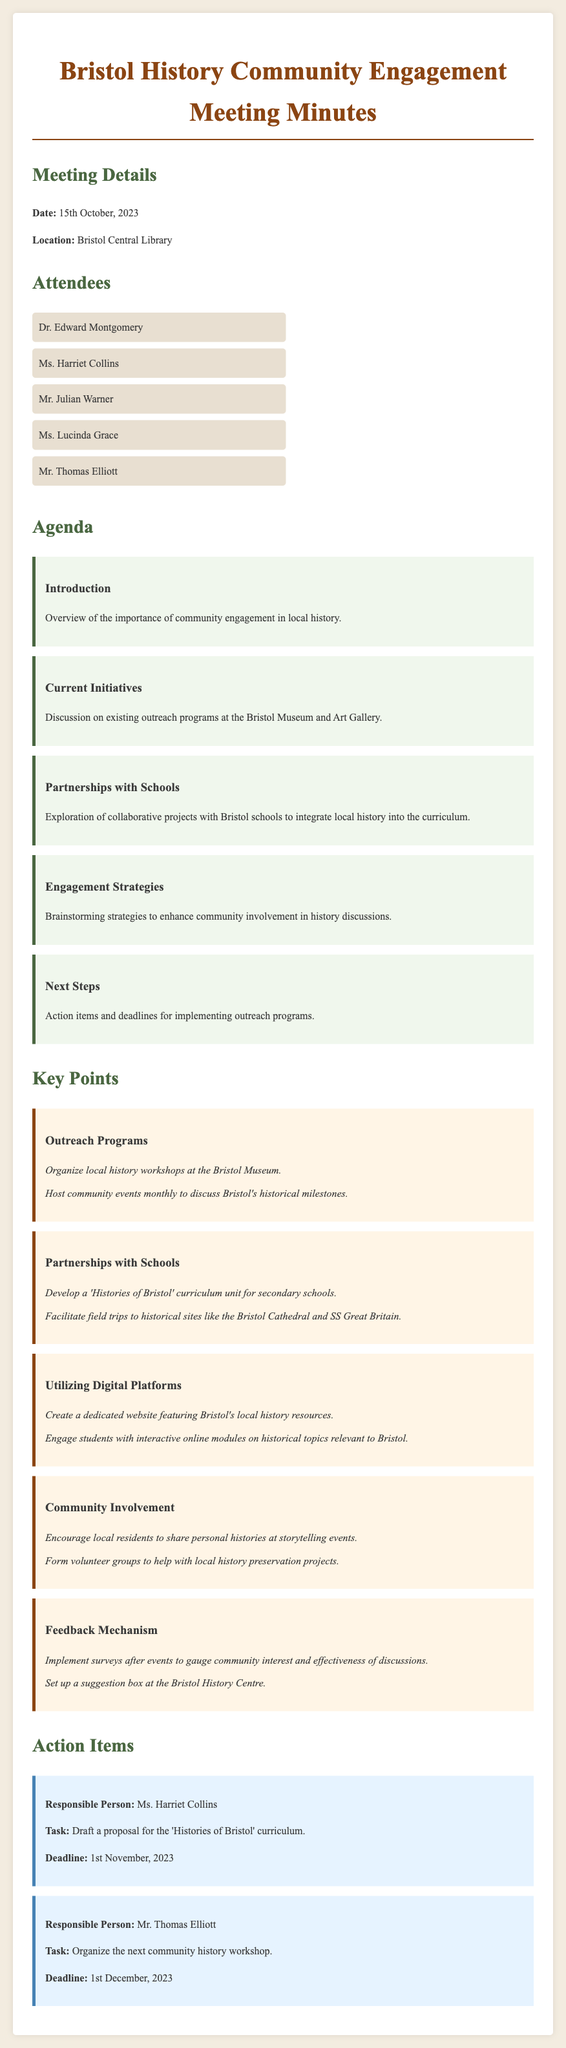What is the date of the meeting? The date of the meeting is explicitly stated in the document under "Meeting Details."
Answer: 15th October, 2023 Who is responsible for drafting the proposal for the 'Histories of Bristol' curriculum? This information is found in the "Action Items" section, where tasks are assigned to individuals.
Answer: Ms. Harriet Collins What was one of the key outreach programs discussed? The key outreach programs are listed under the "Key Points" section, specifically regarding events and workshops.
Answer: Organize local history workshops at the Bristol Museum How many attendees were present at the meeting? The number of attendees can be determined by counting the list provided under the "Attendees" section.
Answer: Five What is one strategy for community involvement mentioned? Strategies for community involvement can be found in the "Key Points" section, specifically related to local residents' engagement.
Answer: Encourage local residents to share personal histories at storytelling events What is the deadline for organizing the next community history workshop? The deadline is clearly outlined in the "Action Items" section related to Mr. Thomas Elliott's task.
Answer: 1st December, 2023 What is the location of the meeting? The location is given in the "Meeting Details" section of the document.
Answer: Bristol Central Library What are the collaborative projects with schools about? The agenda discusses the specifics of partnerships with schools concerning local history.
Answer: Integrate local history into the curriculum 